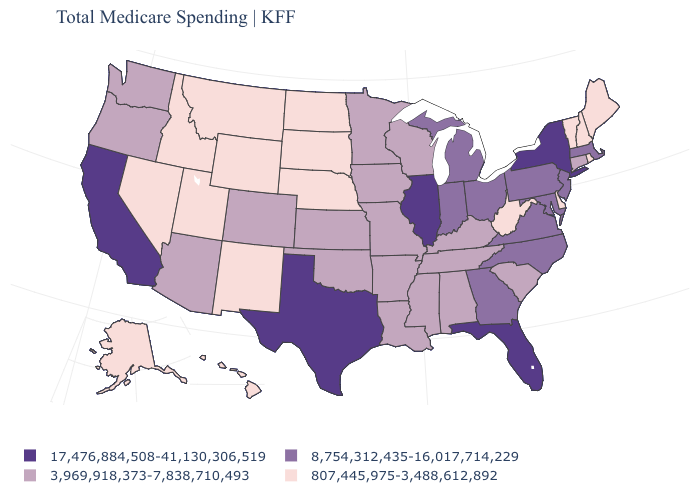Does Mississippi have the highest value in the USA?
Give a very brief answer. No. What is the value of Wisconsin?
Short answer required. 3,969,918,373-7,838,710,493. Which states have the highest value in the USA?
Answer briefly. California, Florida, Illinois, New York, Texas. What is the value of Colorado?
Be succinct. 3,969,918,373-7,838,710,493. What is the value of Washington?
Give a very brief answer. 3,969,918,373-7,838,710,493. What is the lowest value in the South?
Quick response, please. 807,445,975-3,488,612,892. Name the states that have a value in the range 8,754,312,435-16,017,714,229?
Keep it brief. Georgia, Indiana, Maryland, Massachusetts, Michigan, New Jersey, North Carolina, Ohio, Pennsylvania, Virginia. Name the states that have a value in the range 8,754,312,435-16,017,714,229?
Short answer required. Georgia, Indiana, Maryland, Massachusetts, Michigan, New Jersey, North Carolina, Ohio, Pennsylvania, Virginia. Name the states that have a value in the range 17,476,884,508-41,130,306,519?
Keep it brief. California, Florida, Illinois, New York, Texas. What is the value of New Hampshire?
Give a very brief answer. 807,445,975-3,488,612,892. Name the states that have a value in the range 807,445,975-3,488,612,892?
Keep it brief. Alaska, Delaware, Hawaii, Idaho, Maine, Montana, Nebraska, Nevada, New Hampshire, New Mexico, North Dakota, Rhode Island, South Dakota, Utah, Vermont, West Virginia, Wyoming. What is the value of Georgia?
Be succinct. 8,754,312,435-16,017,714,229. Does the first symbol in the legend represent the smallest category?
Be succinct. No. Among the states that border Mississippi , which have the highest value?
Be succinct. Alabama, Arkansas, Louisiana, Tennessee. Does Wyoming have the same value as South Dakota?
Short answer required. Yes. 